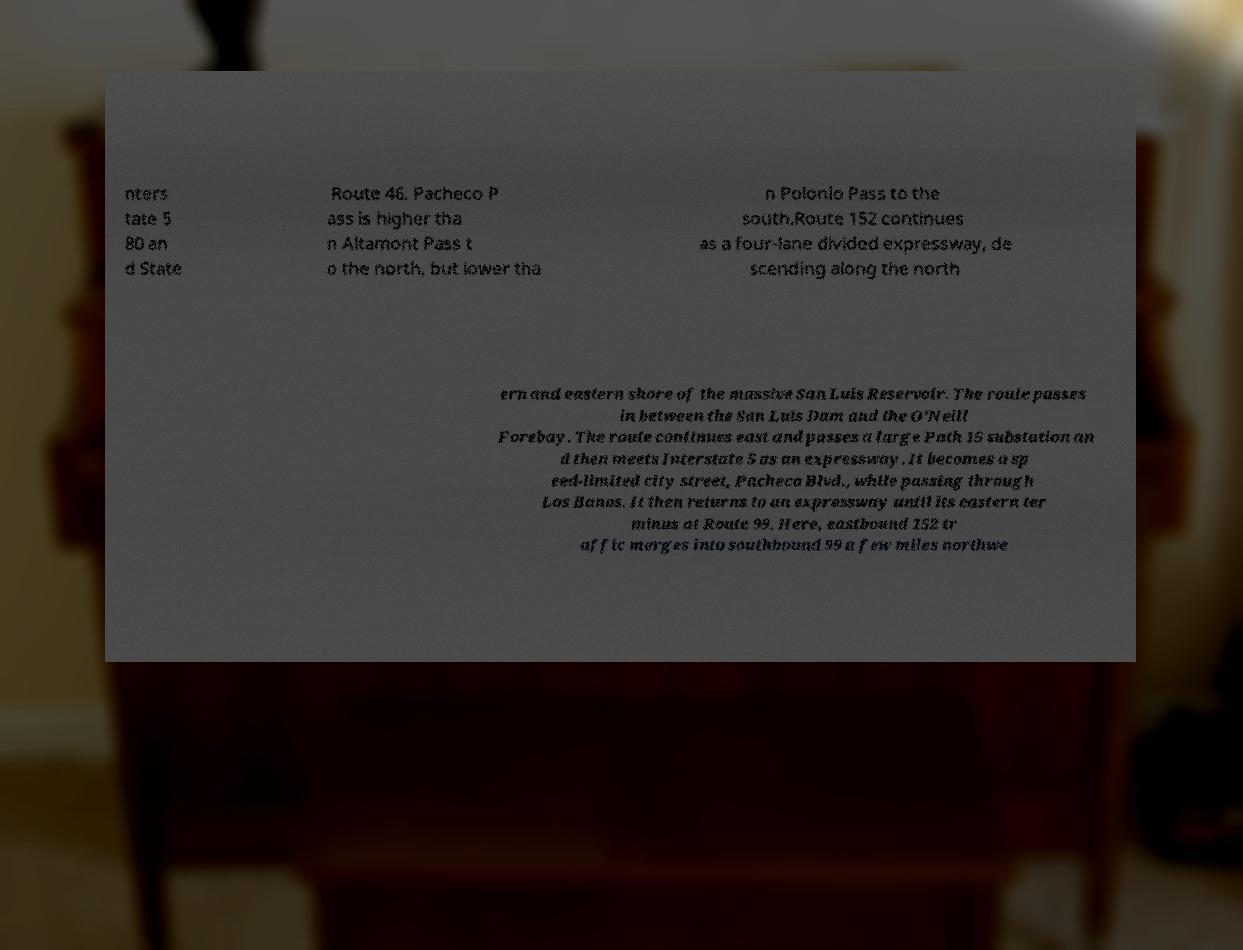Could you extract and type out the text from this image? nters tate 5 80 an d State Route 46. Pacheco P ass is higher tha n Altamont Pass t o the north, but lower tha n Polonio Pass to the south.Route 152 continues as a four-lane divided expressway, de scending along the north ern and eastern shore of the massive San Luis Reservoir. The route passes in between the San Luis Dam and the O'Neill Forebay. The route continues east and passes a large Path 15 substation an d then meets Interstate 5 as an expressway. It becomes a sp eed-limited city street, Pacheco Blvd., while passing through Los Banos. It then returns to an expressway until its eastern ter minus at Route 99. Here, eastbound 152 tr affic merges into southbound 99 a few miles northwe 